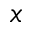Convert formula to latex. <formula><loc_0><loc_0><loc_500><loc_500>x</formula> 